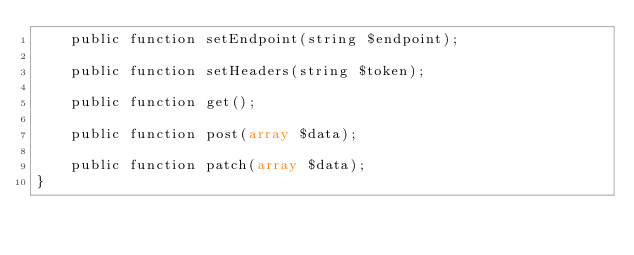<code> <loc_0><loc_0><loc_500><loc_500><_PHP_>    public function setEndpoint(string $endpoint);

    public function setHeaders(string $token);

    public function get();

    public function post(array $data);

    public function patch(array $data);
}
</code> 